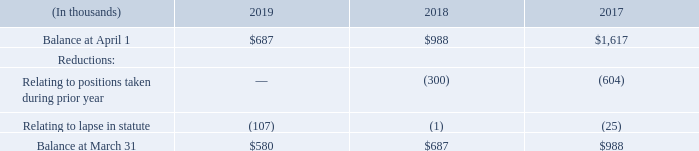We recorded a liability for unrecognized tax positions. The aggregate changes in the balance of our gross unrecognized tax benefits were as follows for the years ended March 31:
As of March 31, 2019, we had a liability of $0.6 million related to uncertain tax positions, the recognition of which would affect our effective income tax rate.
Although the timing and outcome of tax settlements are uncertain, it is reasonably possible that during the next 12 months an immaterial reduction in unrecognized tax benefits may occur as a result of the expiration of various statutes of limitations. We are routinely audited and the outcome of tax examinations could also result in a reduction in unrecognized tax benefits. Other changes could occur in the amount of gross unrecognized tax benefits during the next 12 months which cannot be estimated at this time.
We recognize interest accrued on any unrecognized tax benefits as a component of income tax expense. Penalties are recognized as a component of general and administrative expenses. We recognized interest and penalty expense of less than $0.1 million for the years ended March 31, 2019, 2018 and 2017. As of March 31, 2019 and 2018, we had approximately $0.5 million and $0.8 million of interest and penalties accrued.
In the U.S. we file consolidated federal and state income tax returns where statutes of limitations generally range from three to five years. Although we have resolved examinations with the IRS through tax year ended March 31, 2010, U.S. federal tax years are open from 2006 forward due to attribute carryforwards.
The statute of limitations is open from fiscal year 2012 forward in certain state jurisdictions. We also file income tax returns in international jurisdictions where statutes of limitations generally range from three to seven years. Years beginning after 2008 are open for examination by certain foreign taxing authorities.
What was the liability related to uncertain tax position in 2019? $0.6 million. What was the interest and penalties accrued in 2019? Approximately $0.5 million. When did the statute of limitations open? Fiscal year 2012 forward in certain state jurisdictions. What was the increase / (decrease) in the Balance at April 1 from 2018 to 2019?
Answer scale should be: thousand. 687 - 988
Answer: -301. What was the average relating to lapse in statute for 2017-2019?
Answer scale should be: thousand. -(107 + 1 + 25) / 3
Answer: -44.33. What was the percentage increase / (decrease) in the balance at March 31 from 2018 to 2019?
Answer scale should be: percent. 580 / 687 - 1
Answer: -15.57. 